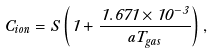<formula> <loc_0><loc_0><loc_500><loc_500>C _ { i o n } = S \left ( 1 + \frac { 1 . 6 7 1 \times 1 0 ^ { - 3 } } { a T _ { g a s } } \right ) ,</formula> 